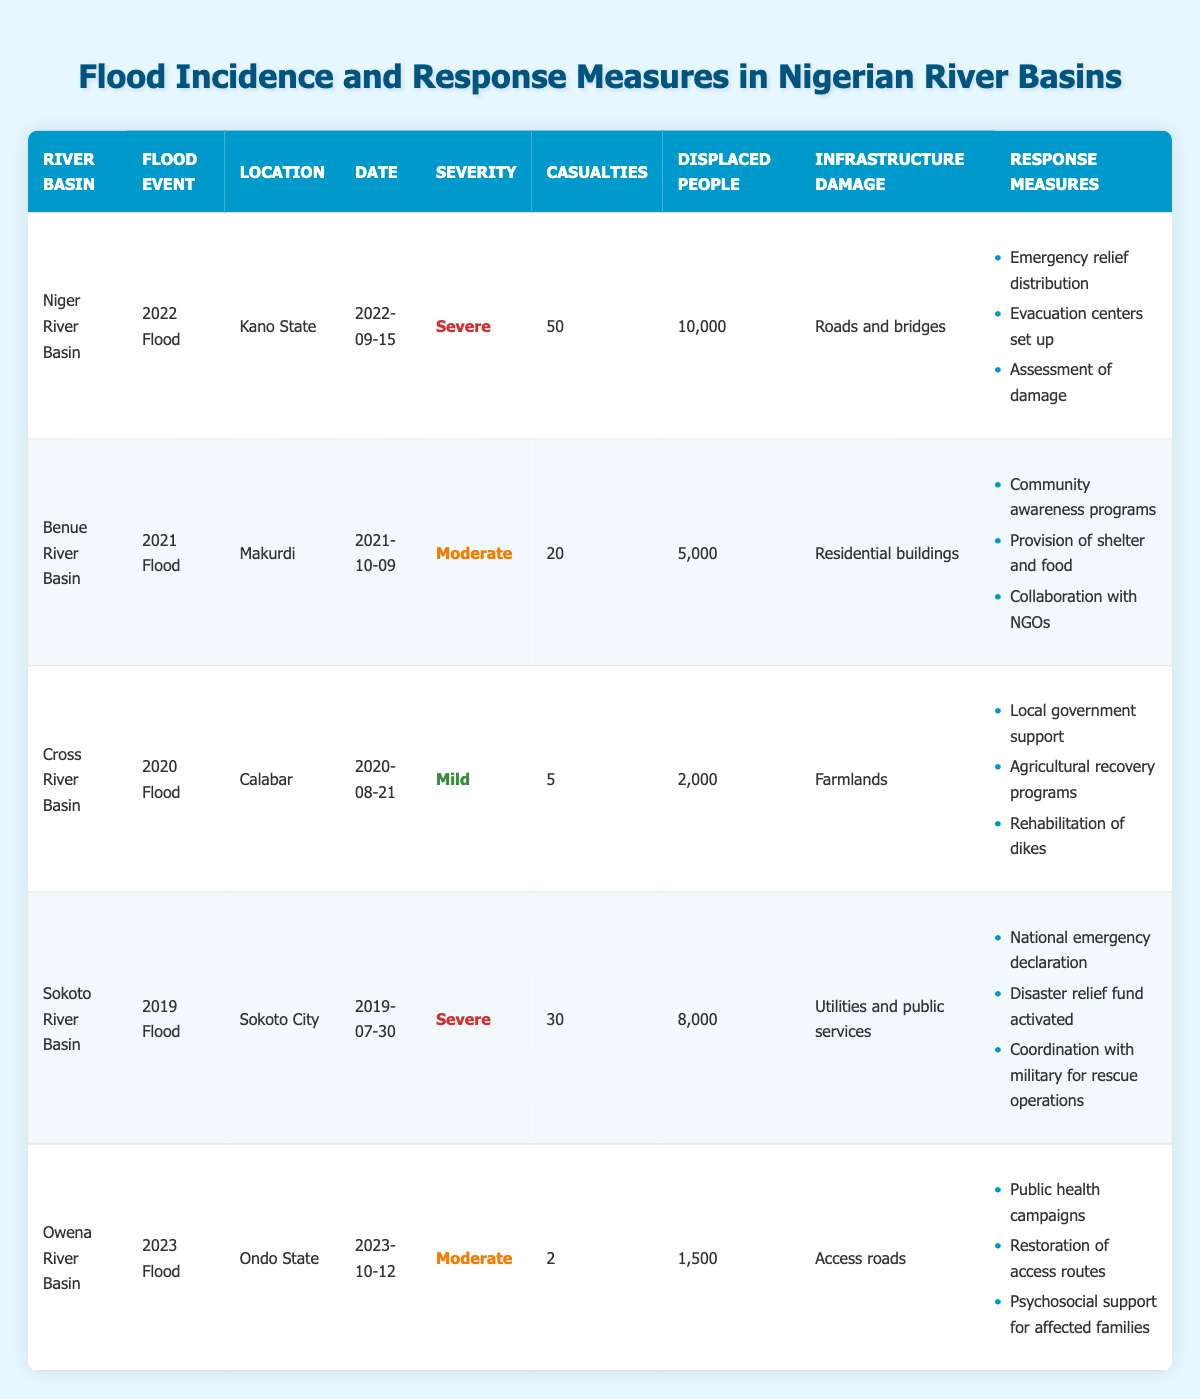What was the severity of the 2022 flood in Kano State? The 2022 flood in Kano State is labeled as "Severe" in the table under the severity column for the Niger River Basin.
Answer: Severe How many total casualties were reported across all flood events? By reviewing the casualties in each event: 50 (Niger) + 20 (Benue) + 5 (Cross) + 30 (Sokoto) + 2 (Owena) = 107, the total casualties are 107.
Answer: 107 Which river basin experienced the most displaced people? The highest displaced people are in the Niger River Basin (10,000) during the 2022 flood. Other river basins had fewer displaced people (5,000, 2,000, 8,000, and 1,500).
Answer: Niger River Basin Did the 2023 flood in Ondo State cause any casualties? There were 2 casualties reported in the 2023 flood in Ondo State, based on the casualties column in the table.
Answer: Yes Which river basin had a flood event with the least casualties? The Cross River Basin had the least casualties with 5 reported during the 2020 flood event.
Answer: Cross River Basin What type of infrastructure was damaged in the 2019 flood in Sokoto City? The infrastructure damage in Sokoto City during the 2019 flood was categorized as "Utilities and public services," as stated in the table.
Answer: Utilities and public services How many total displaced people were reported in the two most severe floods? The two severe floods were in 2022 (Niger, 10,000) and 2019 (Sokoto, 8,000). Adding these gives 10,000 + 8,000 = 18,000 total displaced people in these floods.
Answer: 18,000 Was there a flood in the Benue River Basin that resulted in casualties greater than 20? The Benue River Basin flood in 2021 resulted in 20 casualties, which is not greater than 20, so the answer is no.
Answer: No What response measures were implemented for the 2020 flood in Cross River Basin? In the Cross River Basin, the response measures included local government support, agricultural recovery programs, and rehabilitation of dikes as listed in the respective rows.
Answer: Local government support, agricultural recovery programs, rehabilitation of dikes Compare the casualties between the floods in 2021 and 2022. Which year had more casualties? The 2022 flood in Kano State recorded 50 casualties, while the 2021 flood in Makurdi had 20 casualties. Therefore, 2022 had more casualties.
Answer: 2022 had more casualties What is the average number of displaced people across all listed floods? Total displaced people = (10,000 + 5,000 + 2,000 + 8,000 + 1,500) = 26,500 people. There are 5 events, so average = 26,500 / 5 = 5,300.
Answer: 5,300 